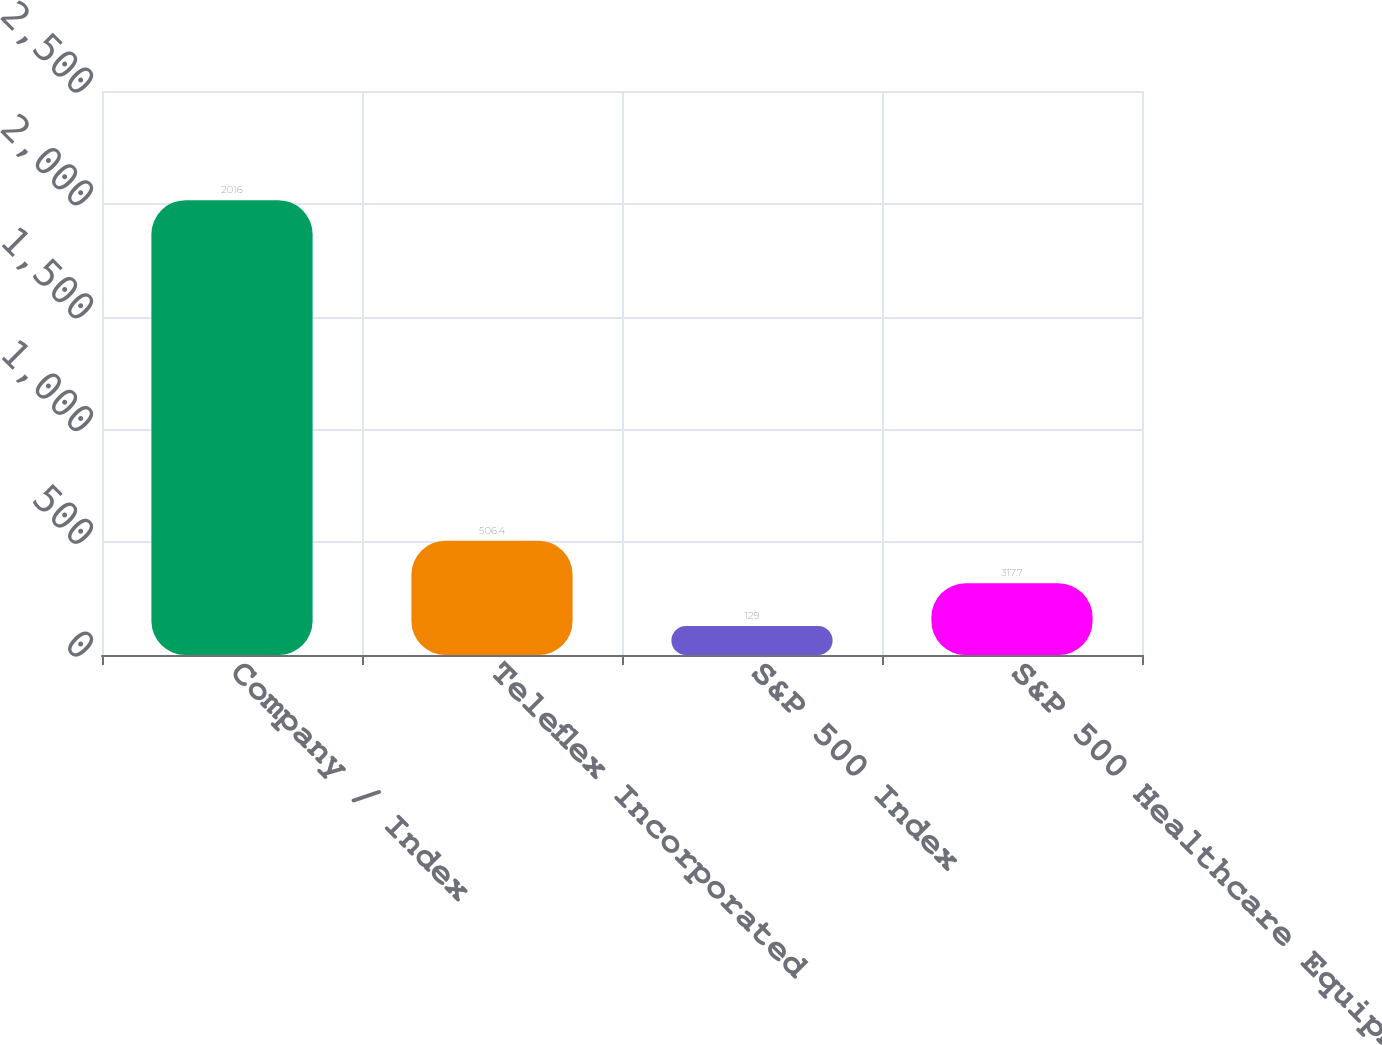Convert chart. <chart><loc_0><loc_0><loc_500><loc_500><bar_chart><fcel>Company / Index<fcel>Teleflex Incorporated<fcel>S&P 500 Index<fcel>S&P 500 Healthcare Equipment &<nl><fcel>2016<fcel>506.4<fcel>129<fcel>317.7<nl></chart> 